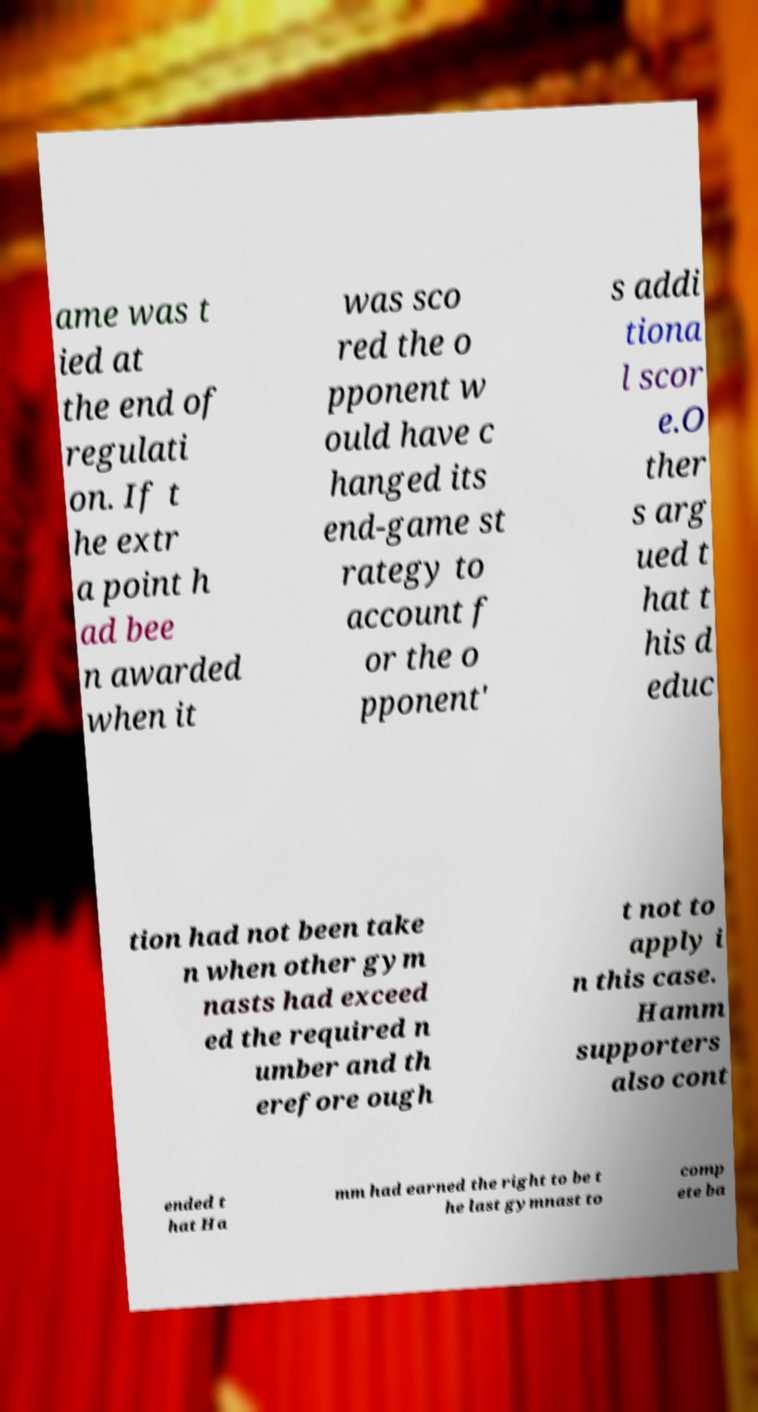There's text embedded in this image that I need extracted. Can you transcribe it verbatim? ame was t ied at the end of regulati on. If t he extr a point h ad bee n awarded when it was sco red the o pponent w ould have c hanged its end-game st rategy to account f or the o pponent' s addi tiona l scor e.O ther s arg ued t hat t his d educ tion had not been take n when other gym nasts had exceed ed the required n umber and th erefore ough t not to apply i n this case. Hamm supporters also cont ended t hat Ha mm had earned the right to be t he last gymnast to comp ete ba 